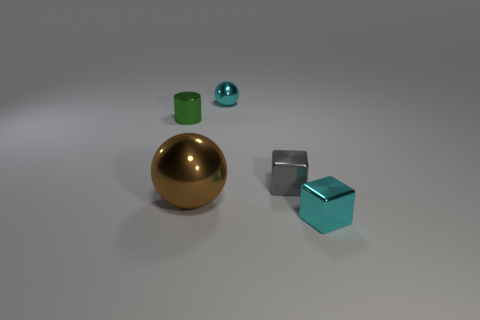Is there any other thing that is the same size as the brown metallic ball?
Offer a terse response. No. The cyan metallic object that is the same shape as the brown metallic object is what size?
Offer a very short reply. Small. There is a small cyan thing that is in front of the tiny metallic sphere; what shape is it?
Keep it short and to the point. Cube. What color is the tiny thing that is in front of the small gray metal block that is in front of the green metallic cylinder?
Provide a succinct answer. Cyan. What number of things are small cyan spheres that are behind the big shiny ball or large blue matte things?
Make the answer very short. 1. There is a brown sphere; is its size the same as the cube behind the large shiny ball?
Provide a succinct answer. No. What number of tiny things are either purple rubber spheres or green metallic things?
Provide a succinct answer. 1. What is the shape of the small green metal object?
Keep it short and to the point. Cylinder. Is there a brown thing that has the same material as the cylinder?
Your response must be concise. Yes. Are there more tiny cyan things than tiny metallic objects?
Your answer should be very brief. No. 